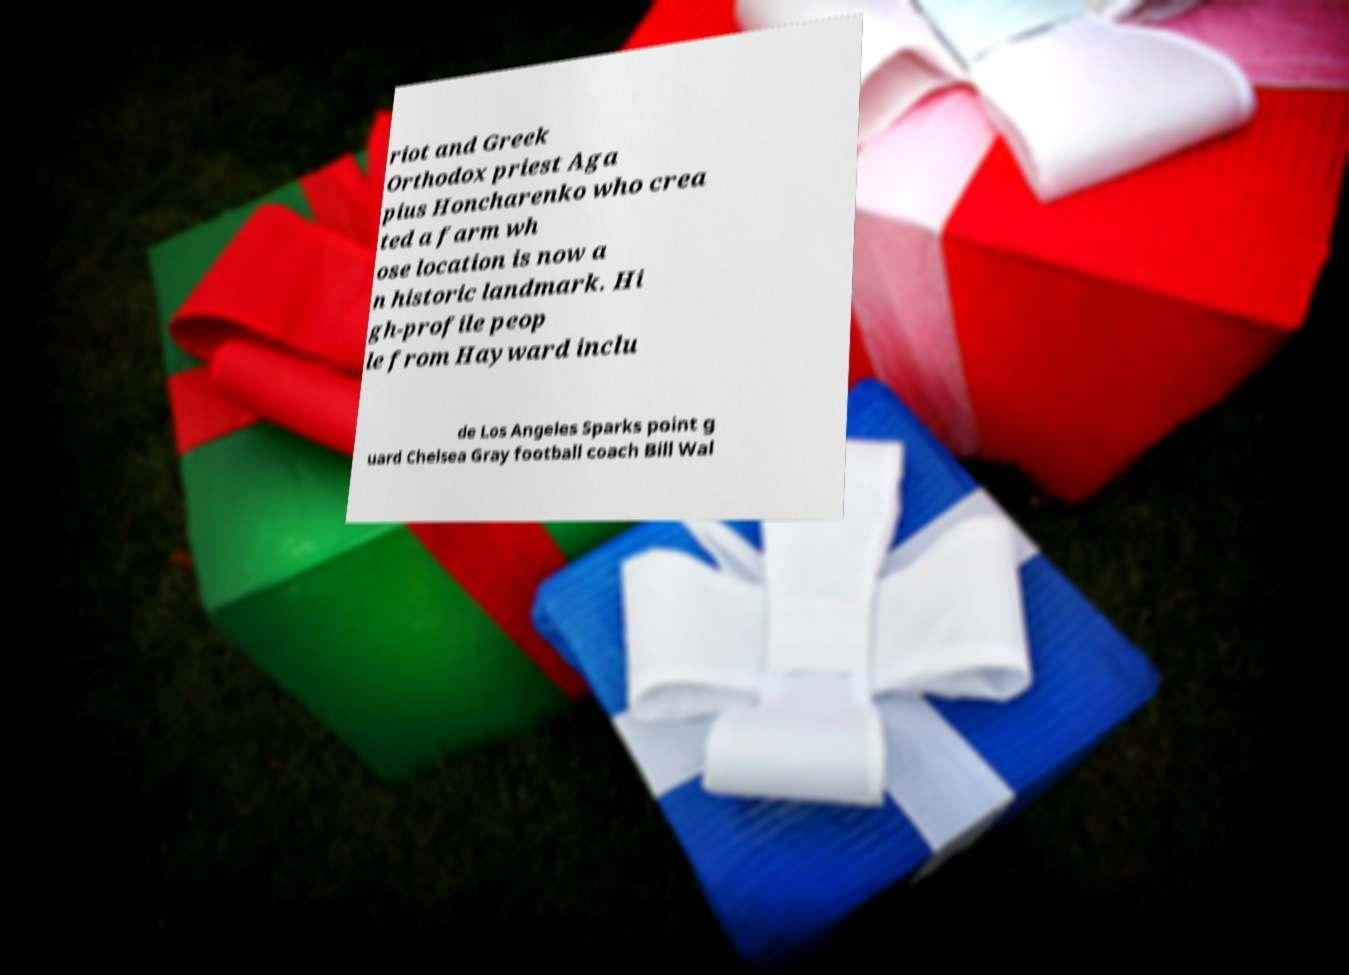Can you accurately transcribe the text from the provided image for me? riot and Greek Orthodox priest Aga pius Honcharenko who crea ted a farm wh ose location is now a n historic landmark. Hi gh-profile peop le from Hayward inclu de Los Angeles Sparks point g uard Chelsea Gray football coach Bill Wal 